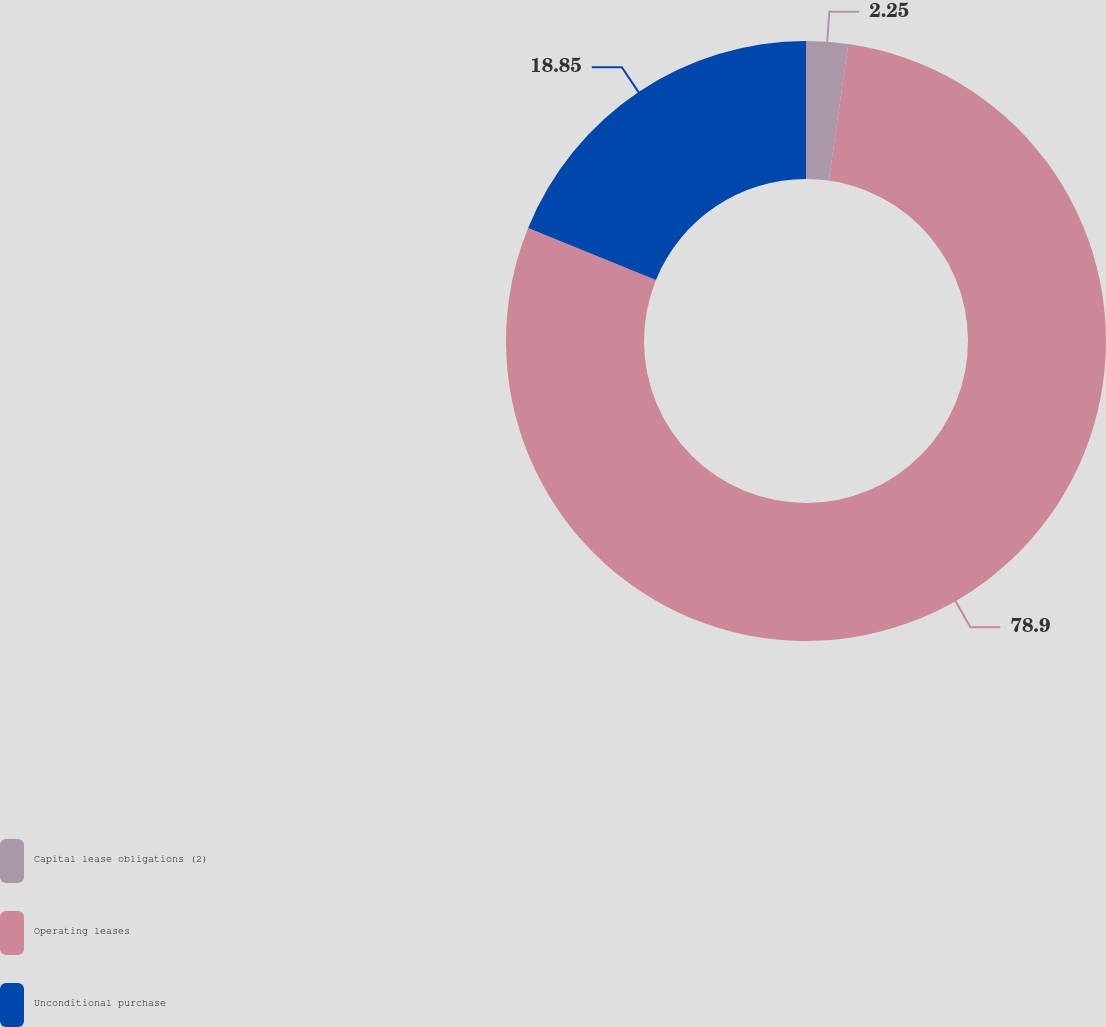Convert chart to OTSL. <chart><loc_0><loc_0><loc_500><loc_500><pie_chart><fcel>Capital lease obligations (2)<fcel>Operating leases<fcel>Unconditional purchase<nl><fcel>2.25%<fcel>78.9%<fcel>18.85%<nl></chart> 